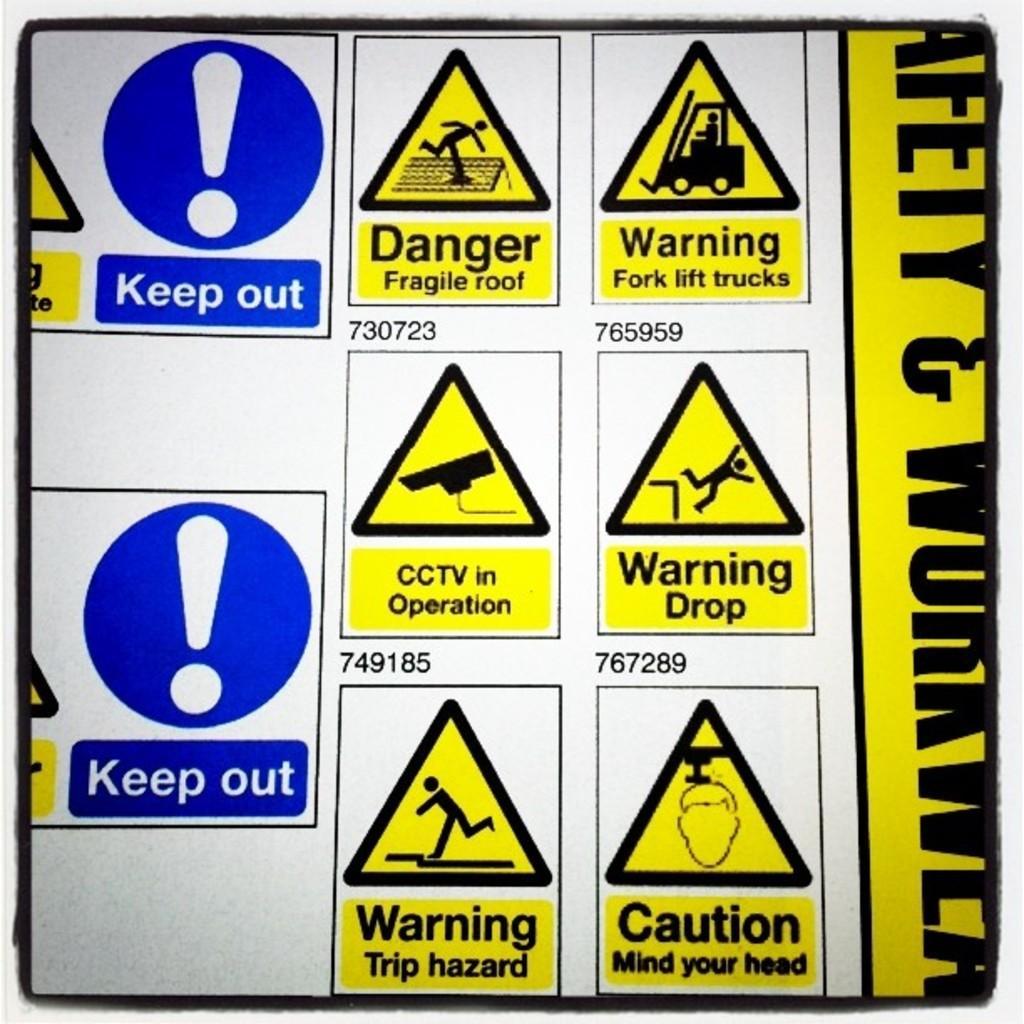In one or two sentences, can you explain what this image depicts? In this image we can see a different signs, it is in yellow color, here is the matter written on it. 